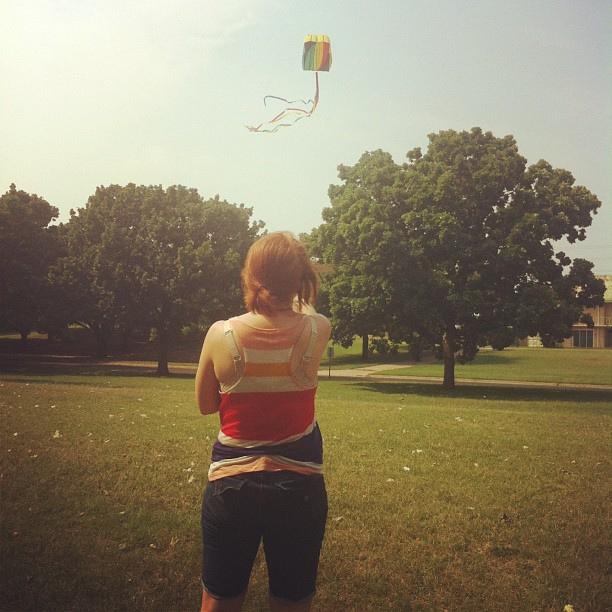Is this a woman or a man?
Keep it brief. Woman. What is the person doing?
Answer briefly. Flying kite. What color is the woman's hair?
Keep it brief. Red. 